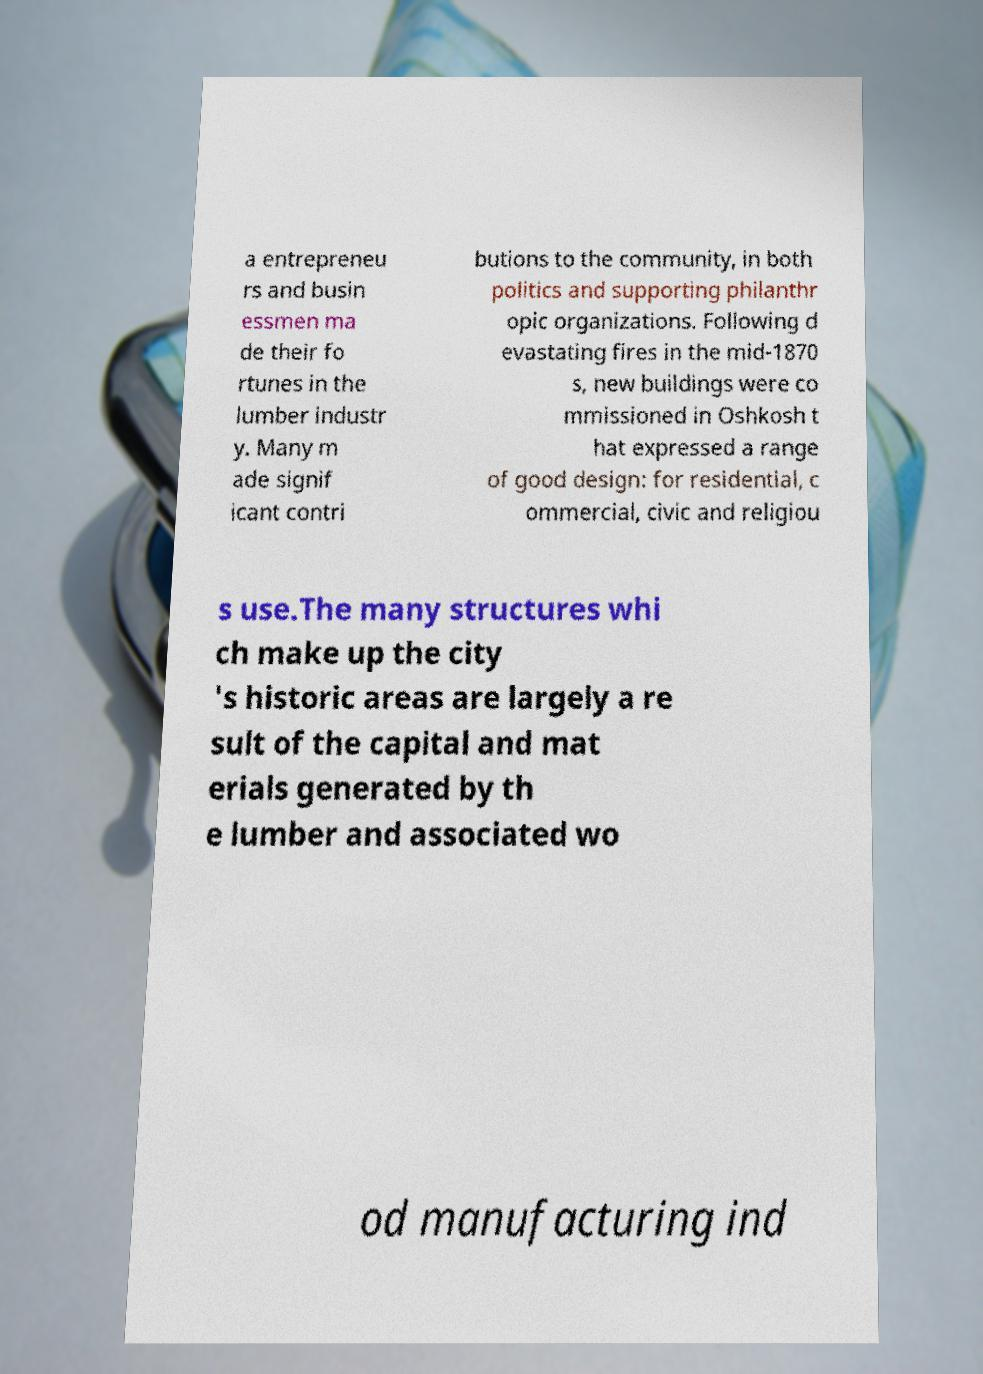What messages or text are displayed in this image? I need them in a readable, typed format. a entrepreneu rs and busin essmen ma de their fo rtunes in the lumber industr y. Many m ade signif icant contri butions to the community, in both politics and supporting philanthr opic organizations. Following d evastating fires in the mid-1870 s, new buildings were co mmissioned in Oshkosh t hat expressed a range of good design: for residential, c ommercial, civic and religiou s use.The many structures whi ch make up the city 's historic areas are largely a re sult of the capital and mat erials generated by th e lumber and associated wo od manufacturing ind 